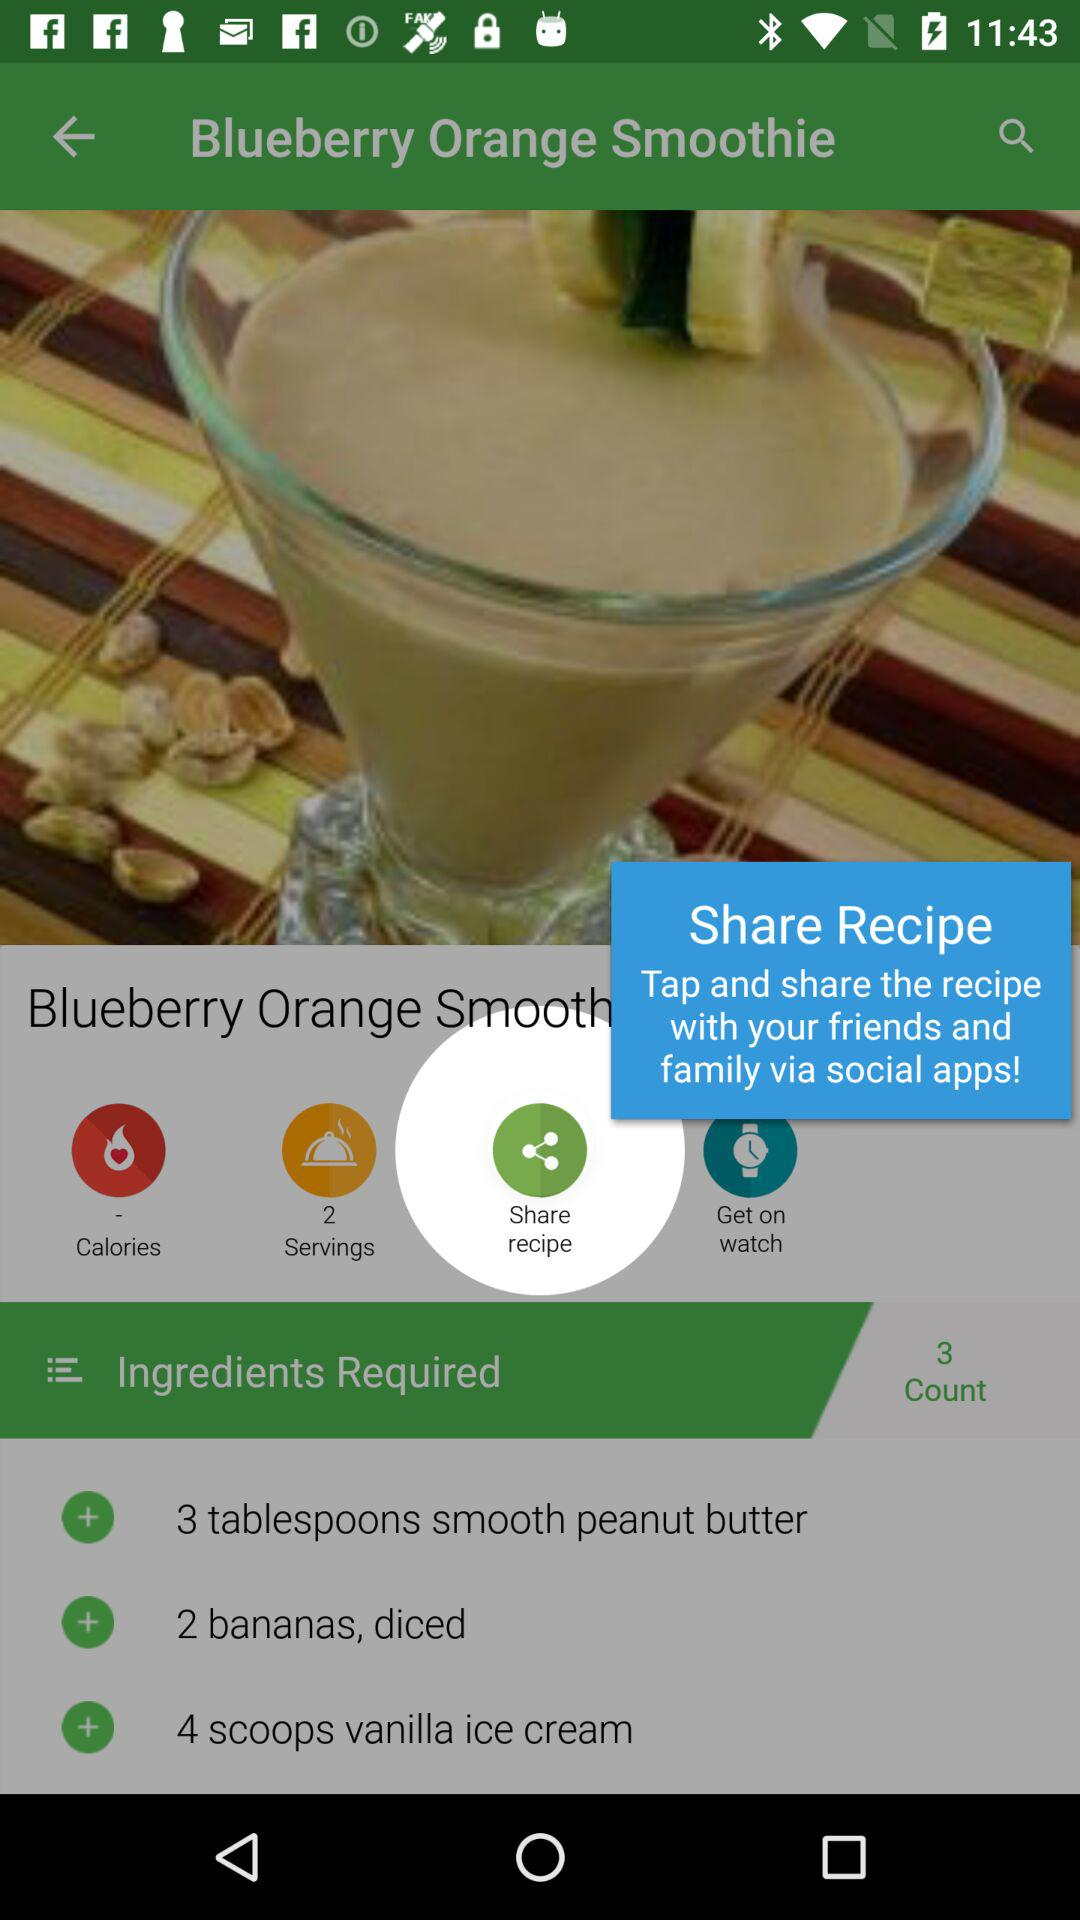How many bananas are required? There are 2 bananas required. 